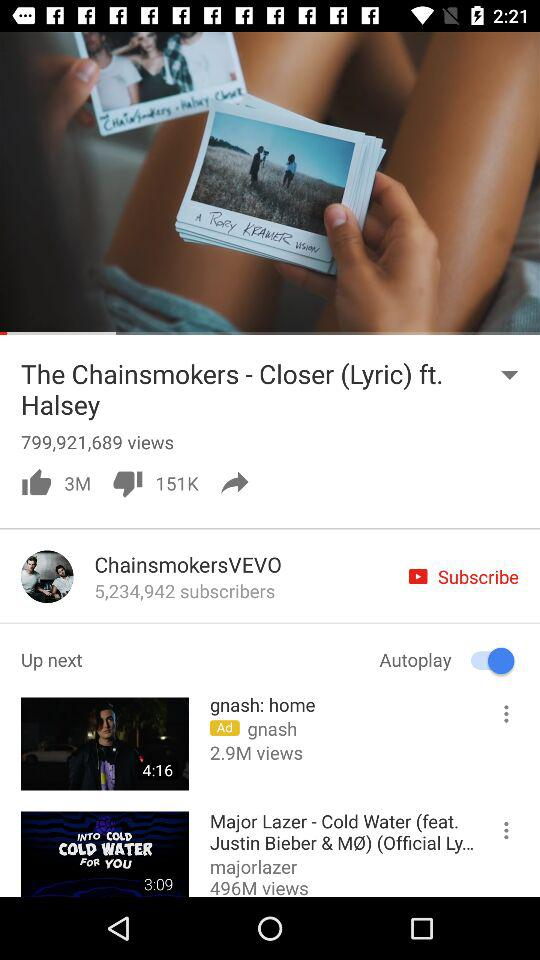How many people disliked "The Chainsmokers - Closer (Lyric) ft. Halsey"? There are 151,000 people. 